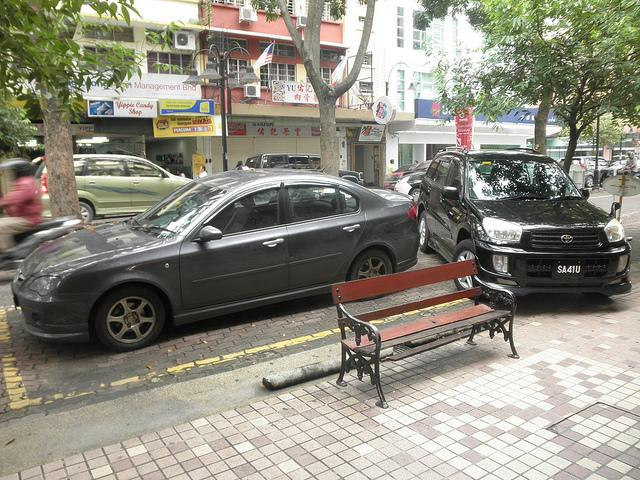Which car violates the law? Please explain your reasoning. black car. The black car can't park behind the gray one. 